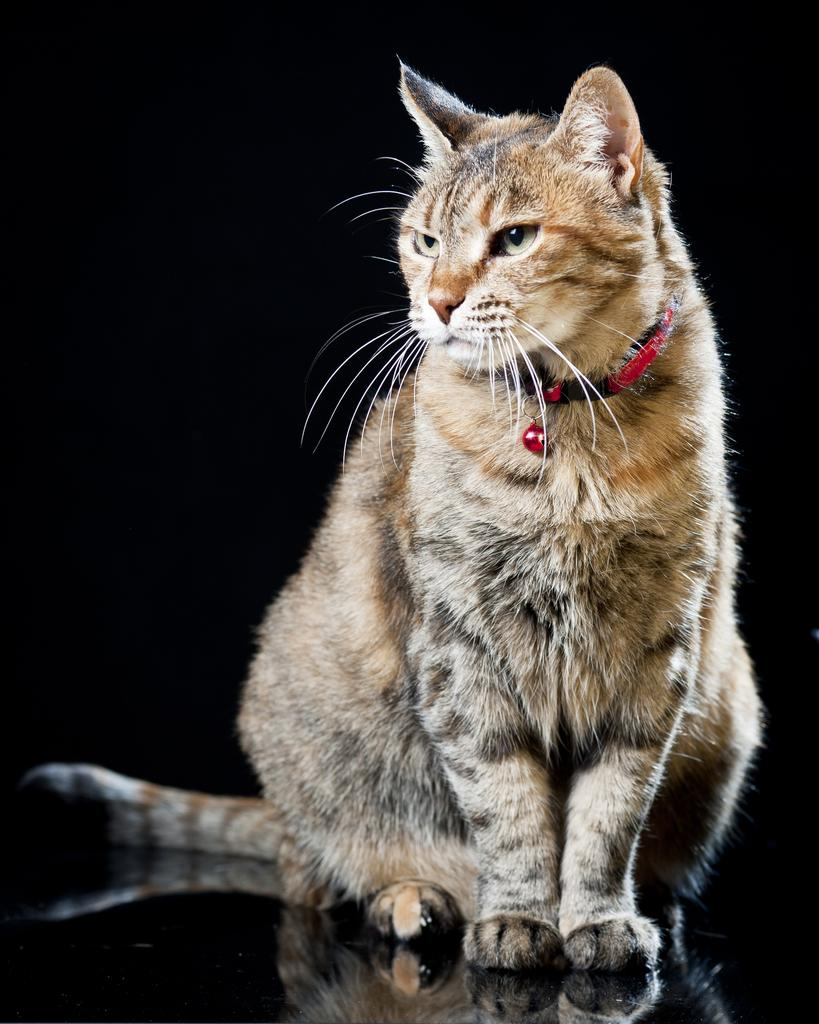What type of animal is in the image? There is a cat in the image. Can you describe the appearance of the cat in the image? The cat has a reflection on a glass in the image. What is the color of the background in the image? The background of the image is dark. What type of tramp can be seen in the image? There is no tramp present in the image; it features a cat with a reflection on a glass. Can you tell me how many worms are crawling on the cat in the image? There are no worms present in the image; it features a cat with a reflection on a glass. 